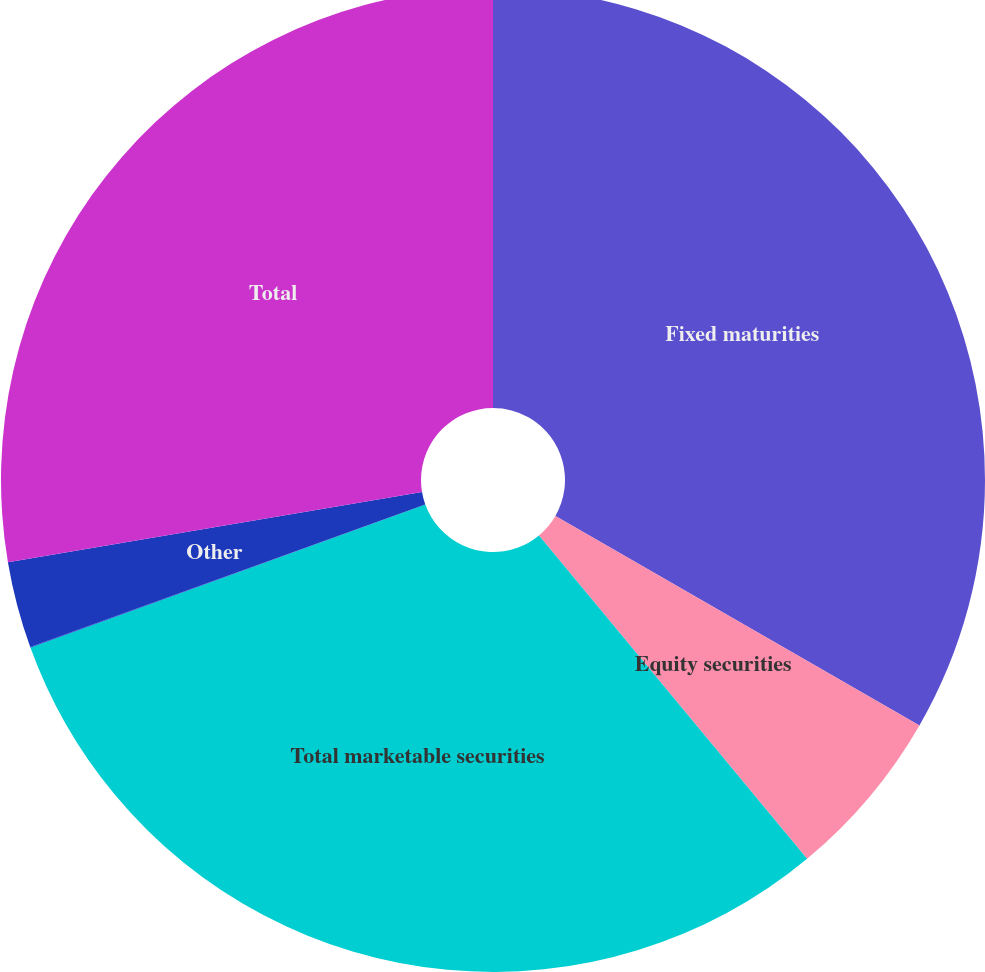<chart> <loc_0><loc_0><loc_500><loc_500><pie_chart><fcel>Fixed maturities<fcel>Equity securities<fcel>Total marketable securities<fcel>Real estate<fcel>Other<fcel>Total<nl><fcel>33.31%<fcel>5.67%<fcel>30.49%<fcel>0.02%<fcel>2.84%<fcel>27.67%<nl></chart> 